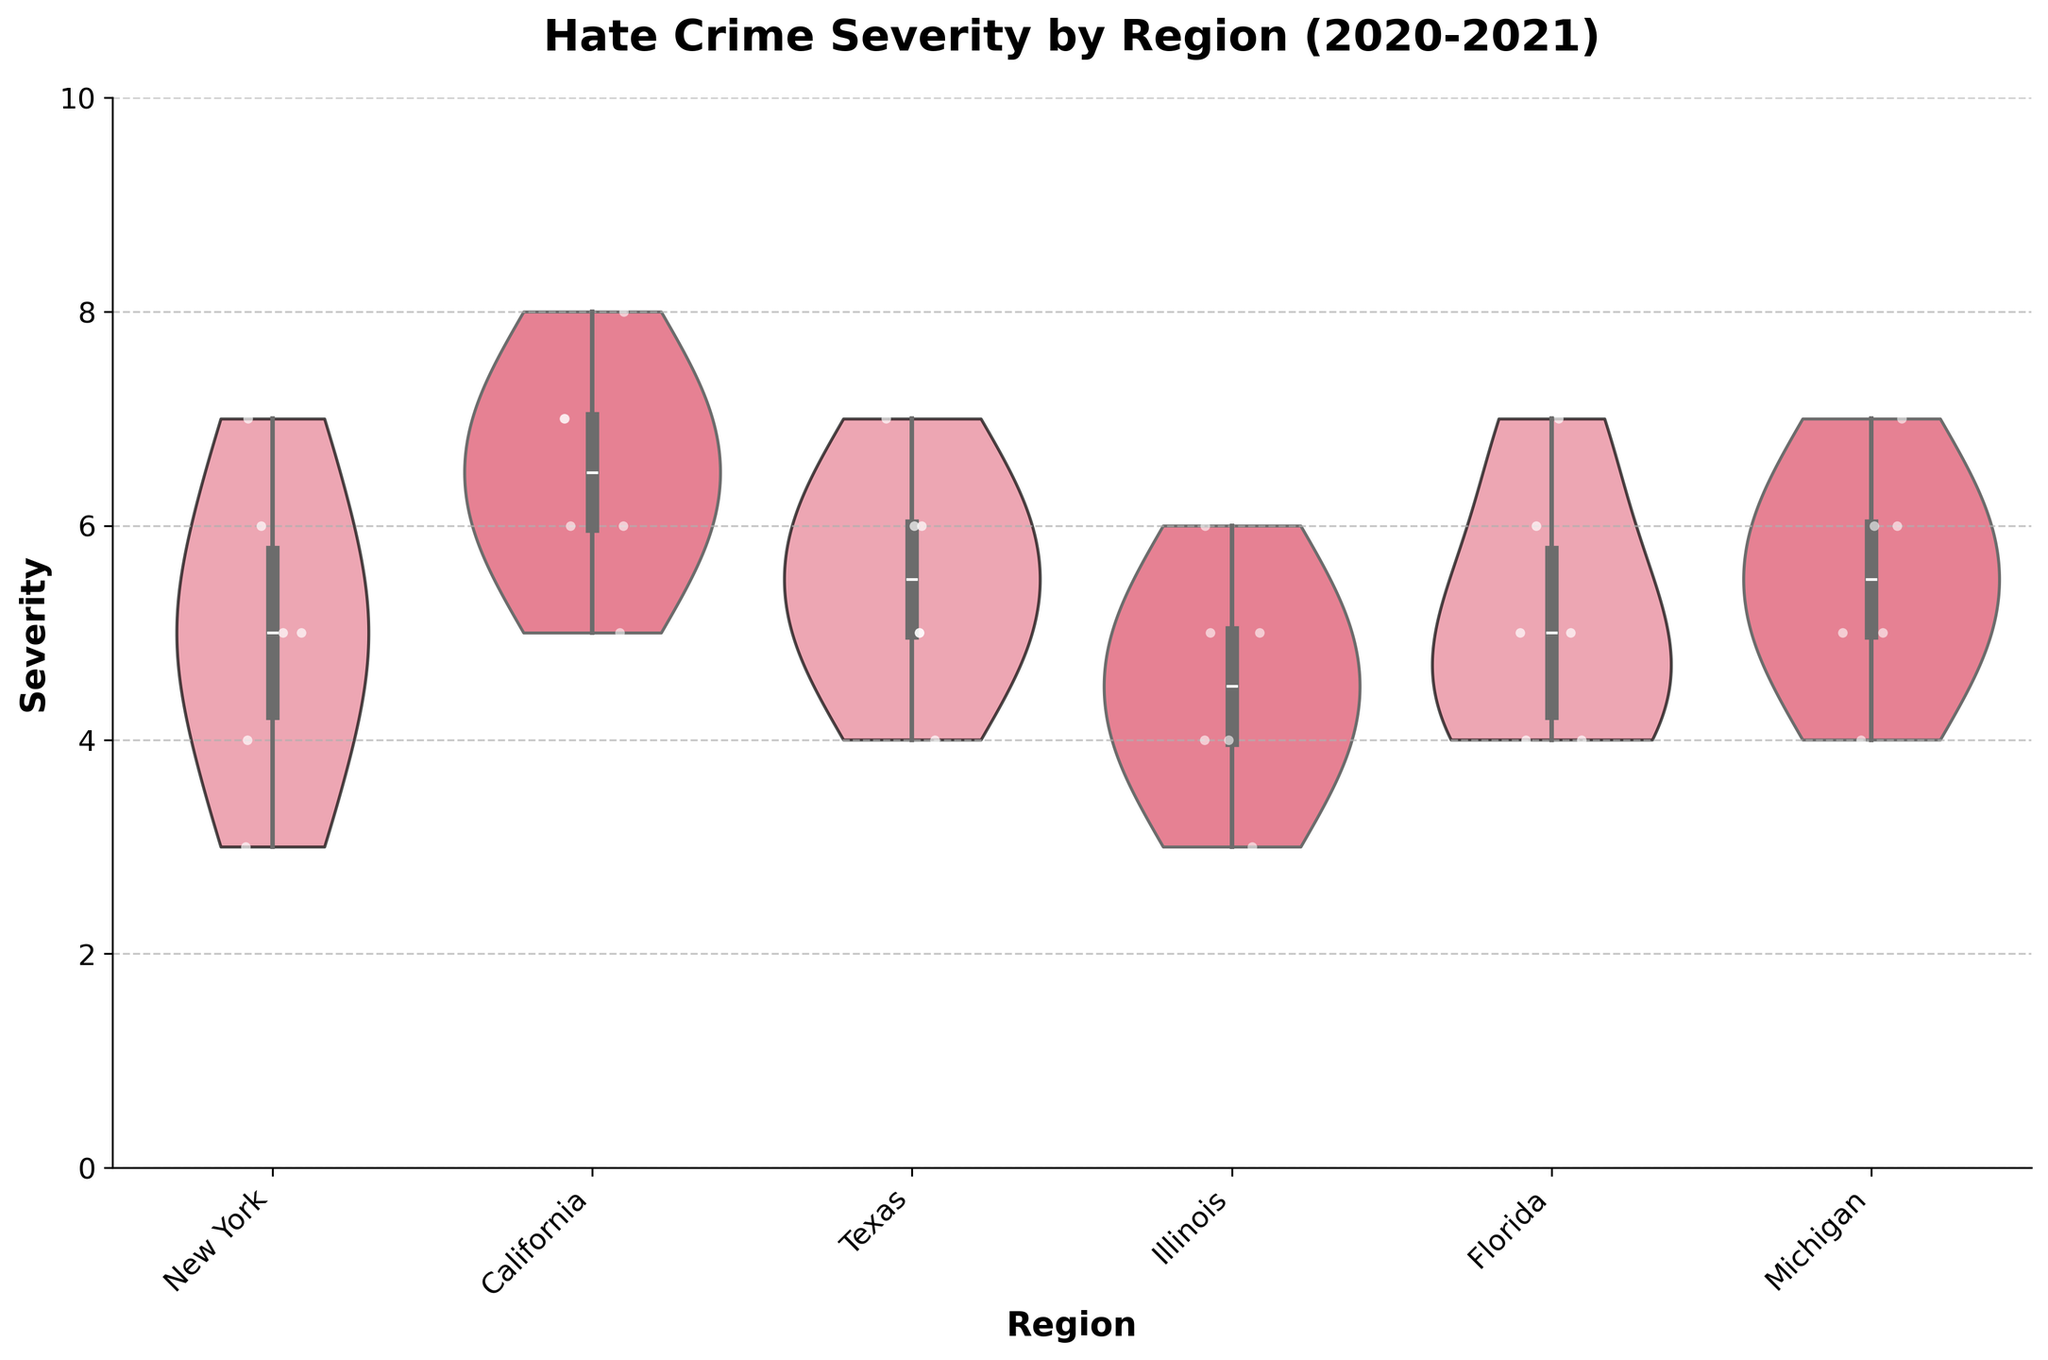What is the title of the figure? The title can be found at the top of the figure, highlighting its purpose.
Answer: Hate Crime Severity by Region (2020-2021) How many regions are shown in the figure? Count the number of unique violin plots along the x-axis, as each represents a different region.
Answer: 6 Which region has the highest median severity of hate crimes? The median is represented by the white dot within the violin plot. Compare the positions of these dots across all regions.
Answer: California Is there a region where hate crime severity appears to be more consistent (less spread)? Look for regions where the width of the violin plot is narrowest, indicating less variability in the data.
Answer: Florida Which region shows the most variability in hate crime severity? Identify the region with the widest violin plot, indicating greater variability in severity.
Answer: California What is the overall range of severity scores displayed in the figure? The y-axis displays severity scores ranging from the minimum to the maximum observed values. Identify the lowest and highest values.
Answer: 0 to 8 Do any regions display a severity score of less than 3? Check each violin plot and jittered points to see if any region has points at or below the severity score of 3 on the y-axis.
Answer: No Which region has the largest difference between the minimum and maximum severity scores? Observe the range within each violin plot (from the bottom to the top) and identify the region with the largest spread.
Answer: California In which regions is the severity of hate crimes changing over time? Examine the overall shape and spread of points within each region's violin plot to see if there are visible trends indicating changes over time, considering each year's variability.
Answer: California and Texas How does the severity of hate crimes in New York compare to that in Florida? Compare the median, range, and spread of the points within the violin plots for New York and Florida.
Answer: New York has higher severity and more variability than Florida 